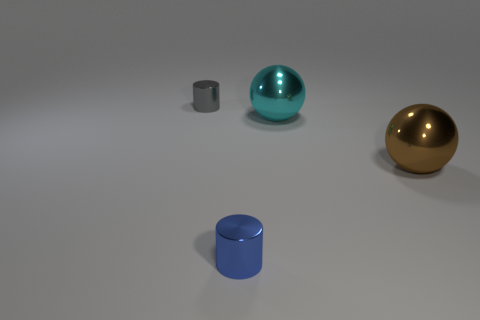Subtract all gray balls. Subtract all green blocks. How many balls are left? 2 Add 3 large brown objects. How many objects exist? 7 Subtract 0 green balls. How many objects are left? 4 Subtract all metallic things. Subtract all large blue objects. How many objects are left? 0 Add 3 cylinders. How many cylinders are left? 5 Add 2 red shiny cylinders. How many red shiny cylinders exist? 2 